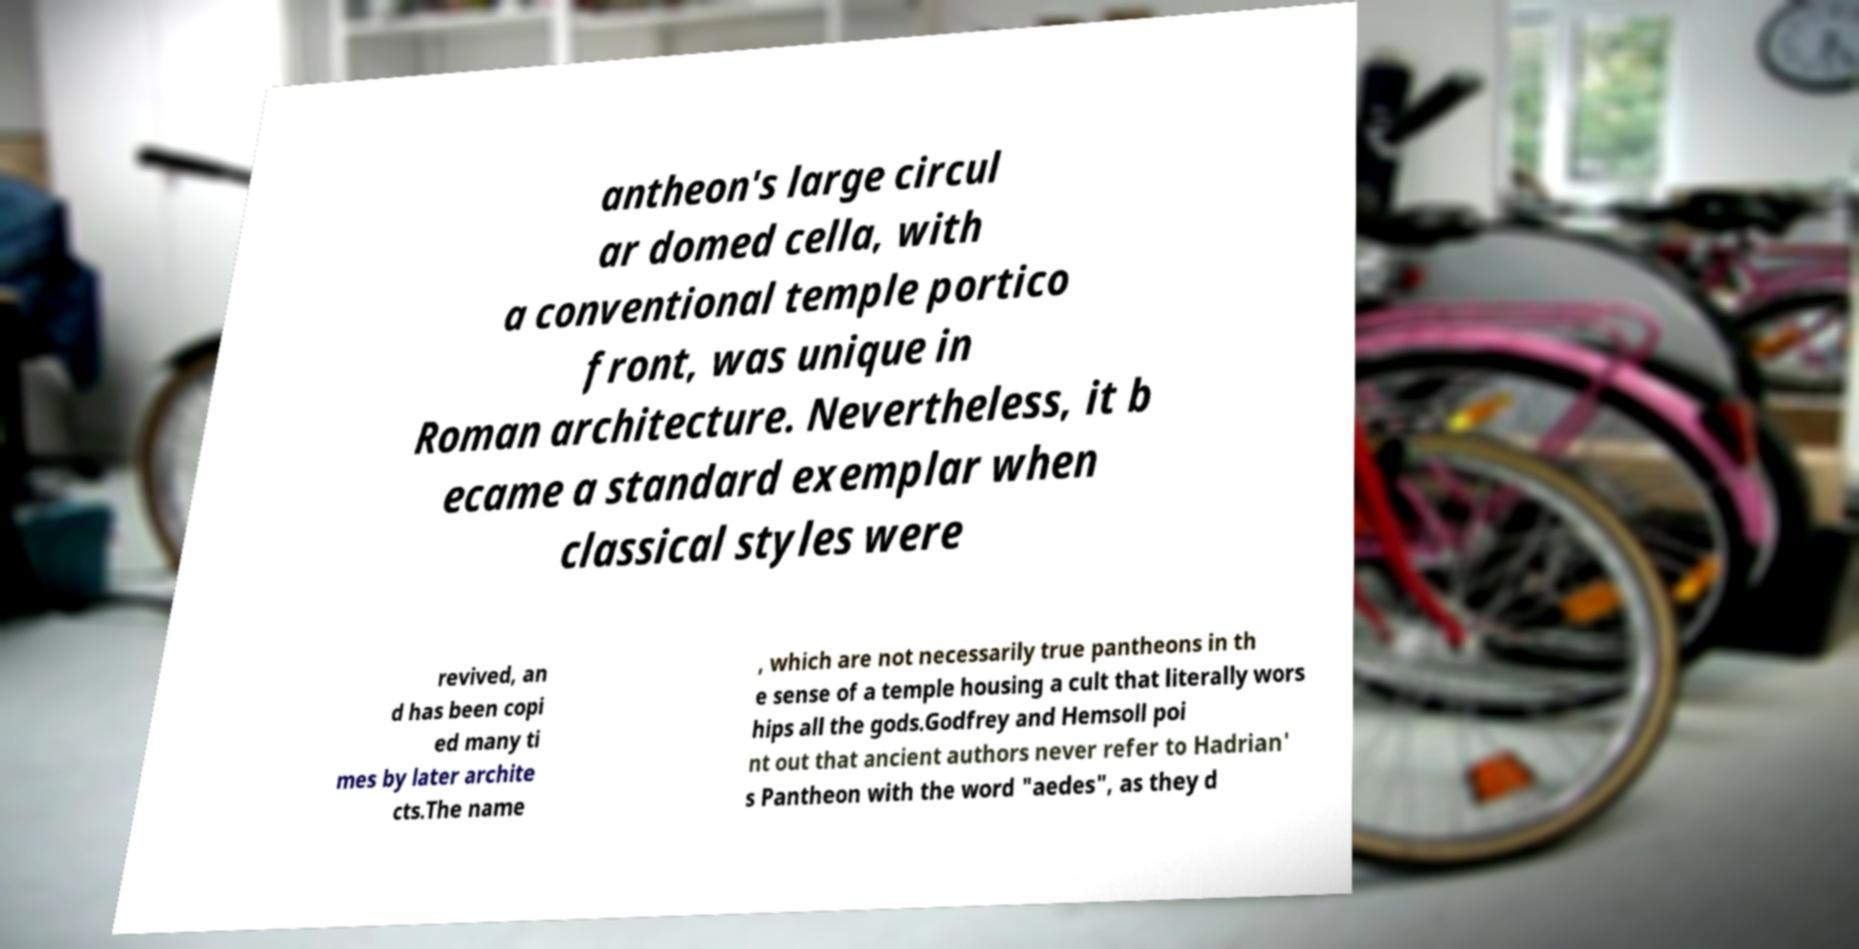For documentation purposes, I need the text within this image transcribed. Could you provide that? antheon's large circul ar domed cella, with a conventional temple portico front, was unique in Roman architecture. Nevertheless, it b ecame a standard exemplar when classical styles were revived, an d has been copi ed many ti mes by later archite cts.The name , which are not necessarily true pantheons in th e sense of a temple housing a cult that literally wors hips all the gods.Godfrey and Hemsoll poi nt out that ancient authors never refer to Hadrian' s Pantheon with the word "aedes", as they d 